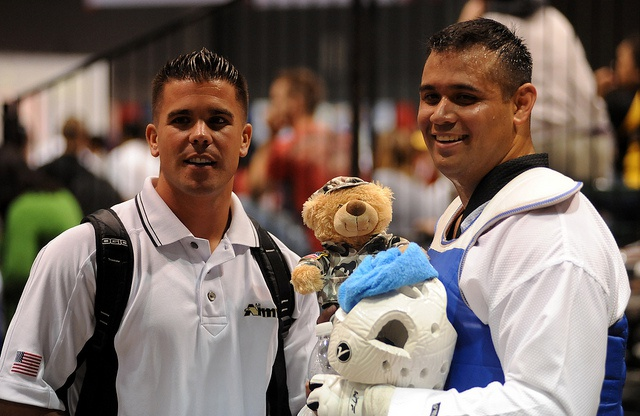Describe the objects in this image and their specific colors. I can see people in black, darkgray, gray, and lightgray tones, people in black, lightgray, maroon, and brown tones, people in black, tan, and gray tones, people in black, maroon, brown, and gray tones, and backpack in black, gray, and darkgray tones in this image. 